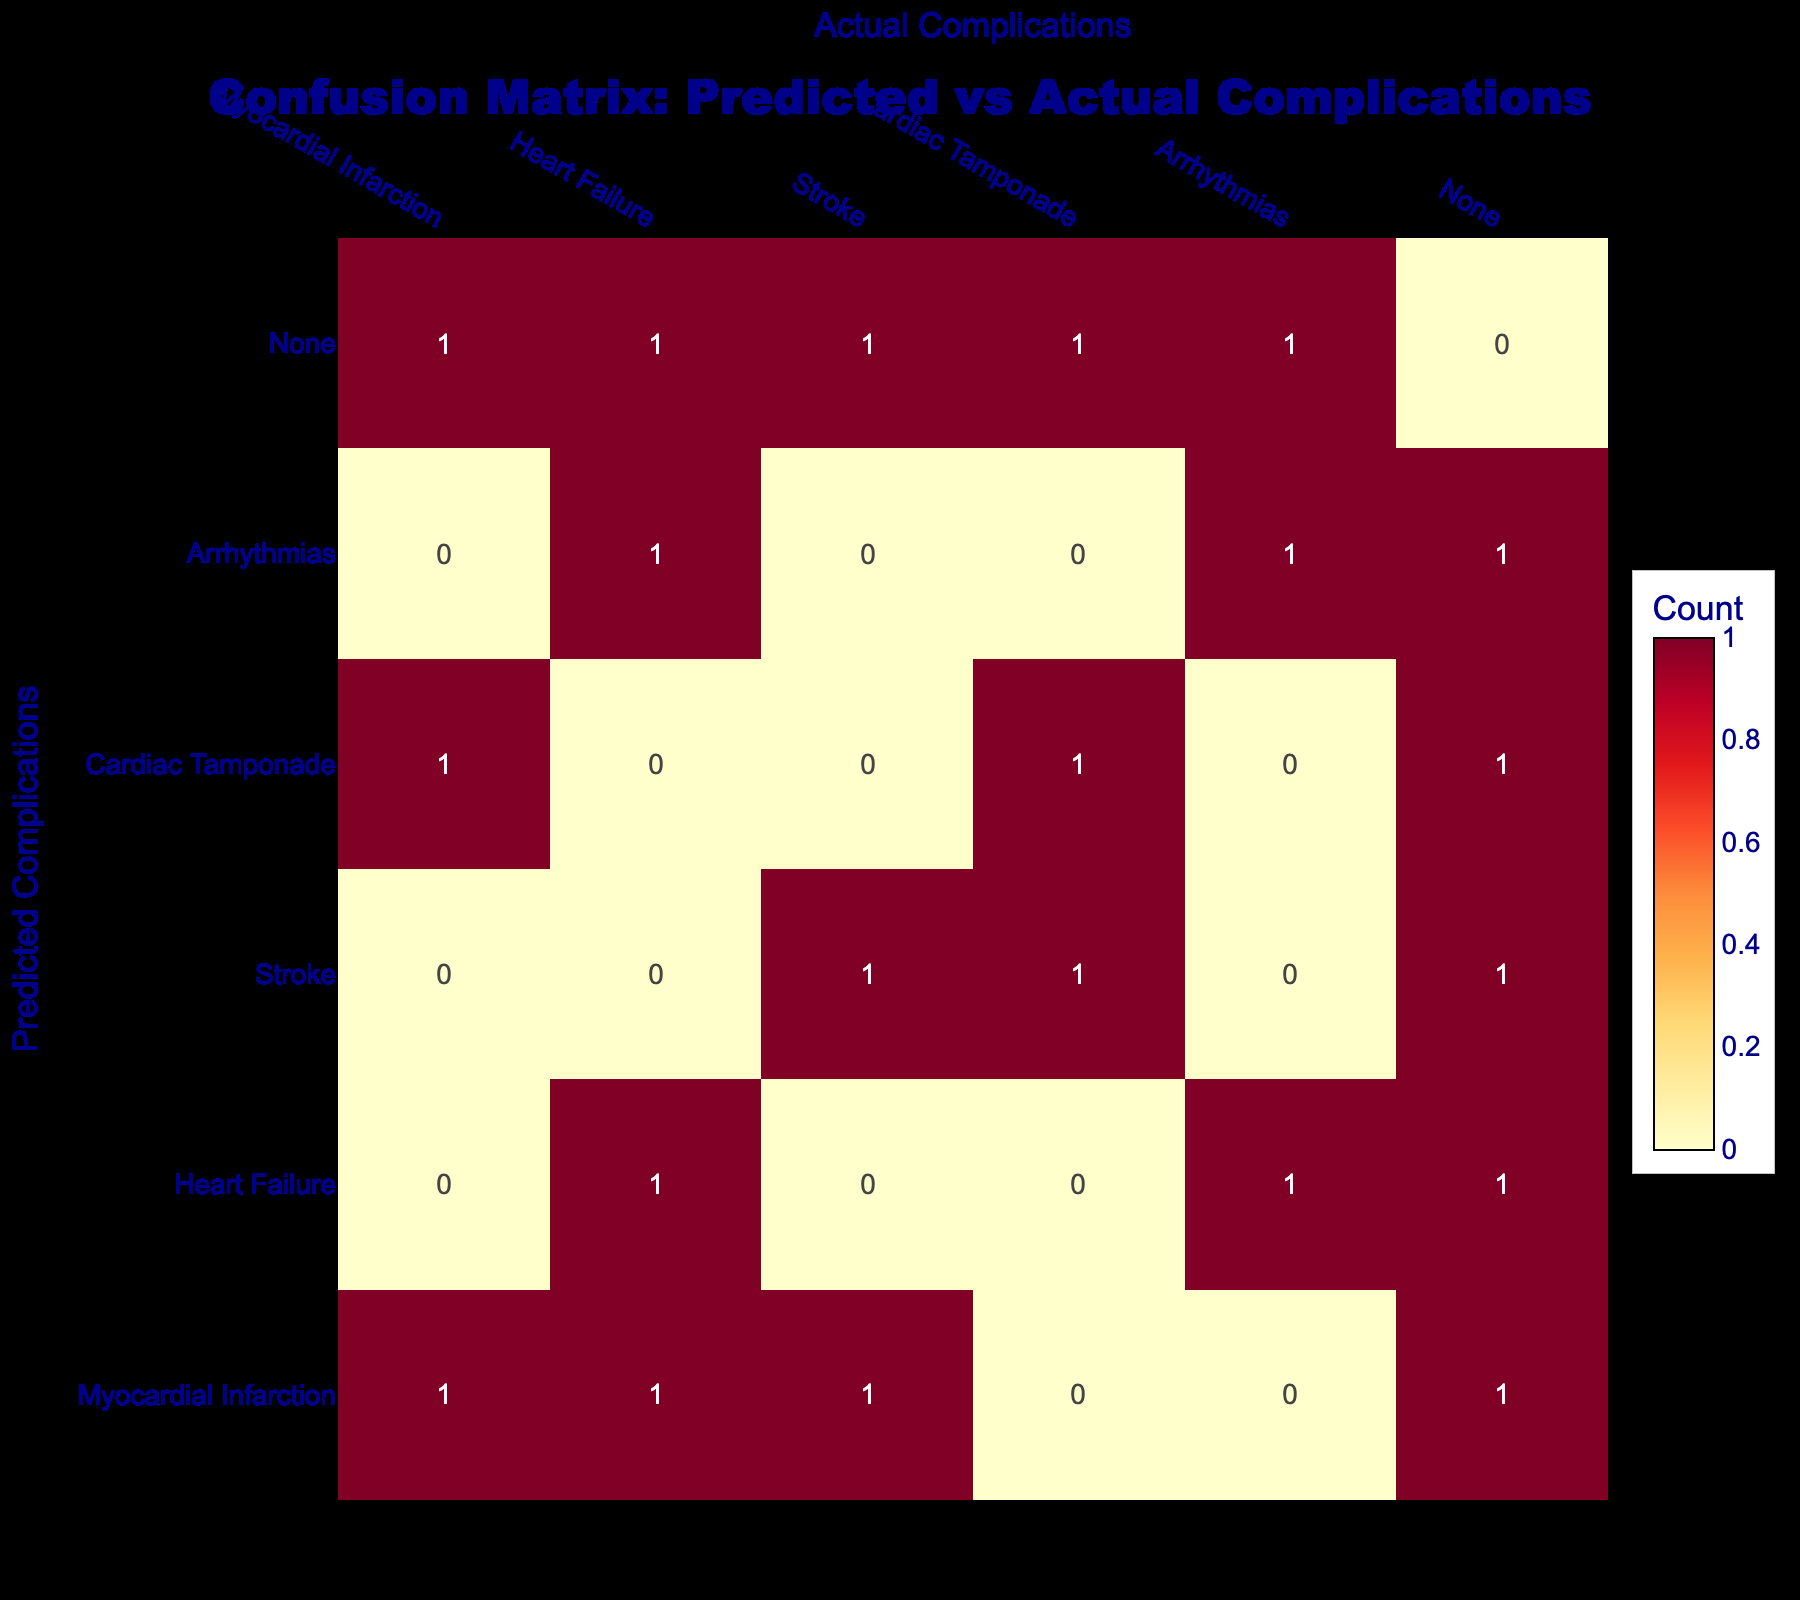What is the count of actual Myocardial Infarction predicted as Myocardial Infarction? In the table, we look at the row where the predicted complications are "Myocardial Infarction" and find the actual complications column value that matches it. There is 1 entry where both predicted and actual complications are "Myocardial Infarction".
Answer: 1 How many times was Heart Failure predicted as None? We examine the row for "None" as the predicted complication and check the actual complications column for "Heart Failure". There are 1 entry for this case.
Answer: 1 What is the total number of times Stroke was predicted across all actual complications? To find this, we add all the values in the row for "Stroke" in the predicted complications column. The corresponding values for all actual complications are 1 (for Stroke) + 1 (for Cardiac Tamponade) + 1 (for None) = 3.
Answer: 3 Did any predictions result in a correct match for Arrhythmias? We can check the row where predicted complications are "Arrhythmias" and see if it matches with the actual complications. There is 1 entry where both are "Arrhythmias", which confirms a correct match.
Answer: Yes Is there a case where Myocardial Infarction was predicted while the actual complication was Cardiac Tamponade? Looking in the row for "Myocardial Infarction", we see that one of the actual complication entries is indeed "Cardiac Tamponade". Therefore, this case exists.
Answer: Yes What is the difference between the number of times Heart Failure was predicted and the number of times None was predicted? We count the occurrences of "Heart Failure" predicted (2) and those predicted as "None" (5). The difference is 5 - 2 = 3.
Answer: 3 How many complications were predicted as None? We check the row where "None" is listed as the predicted complication and count all occurrences across different actual complications. There are 5 occurrences for "None" predicted for the different actual complications.
Answer: 5 What is the average number of correct predictions for the complication types listed? By looking at the diagonal from the confusion matrix, the correct predictions are Myocardial Infarction (1), Heart Failure (1), Stroke (1), Cardiac Tamponade (1), and Arrhythmias (1), totaling 5. Since there are 5 complication types, the average is 5/5 = 1.
Answer: 1 How many times were complications predicted as both Myocardial Infarction and Stroke? In the confusion matrix, we look for predicted complications that show "Myocardial Infarction" and "Stroke" as actual complications. For "Myocardial Infarction", there are 1 occurrences matching "Stroke".
Answer: 1 